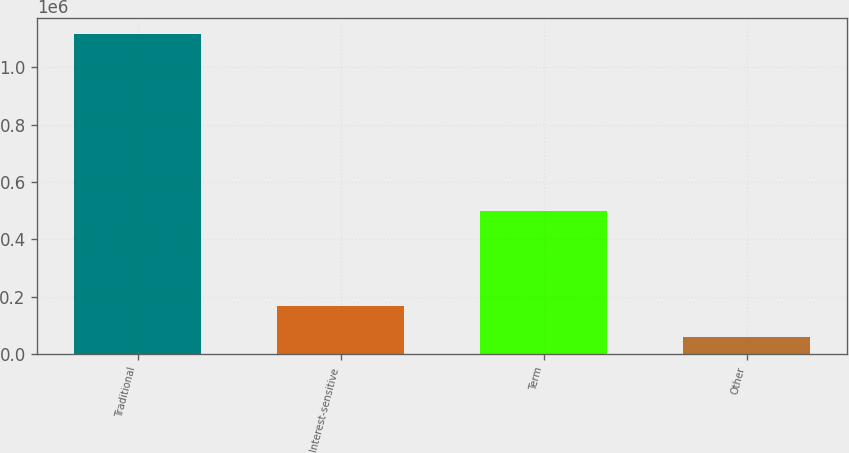Convert chart. <chart><loc_0><loc_0><loc_500><loc_500><bar_chart><fcel>Traditional<fcel>Interest-sensitive<fcel>Term<fcel>Other<nl><fcel>1.11578e+06<fcel>166664<fcel>499814<fcel>61207<nl></chart> 